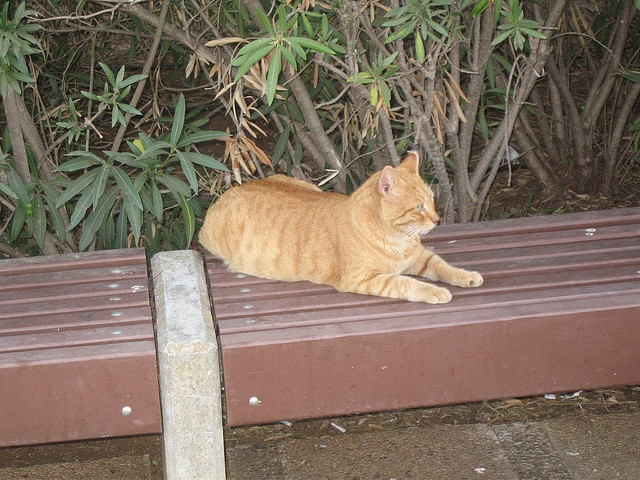Describe the objects in this image and their specific colors. I can see bench in black, gray, and darkgray tones, bench in black, gray, and darkgray tones, and cat in black, tan, and gray tones in this image. 